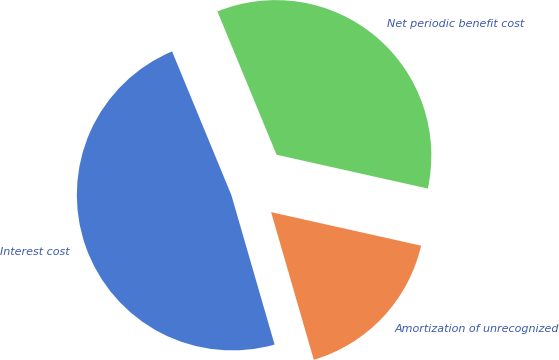Convert chart. <chart><loc_0><loc_0><loc_500><loc_500><pie_chart><fcel>Interest cost<fcel>Amortization of unrecognized<fcel>Net periodic benefit cost<nl><fcel>48.25%<fcel>17.02%<fcel>34.73%<nl></chart> 